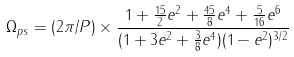Convert formula to latex. <formula><loc_0><loc_0><loc_500><loc_500>\Omega _ { p s } = ( 2 \pi / P ) \times \frac { 1 + \frac { 1 5 } { 2 } e ^ { 2 } + \frac { 4 5 } { 8 } e ^ { 4 } + \frac { 5 } { 1 6 } e ^ { 6 } } { ( 1 + 3 e ^ { 2 } + \frac { 3 } { 8 } e ^ { 4 } ) ( 1 - e ^ { 2 } ) ^ { 3 / 2 } }</formula> 